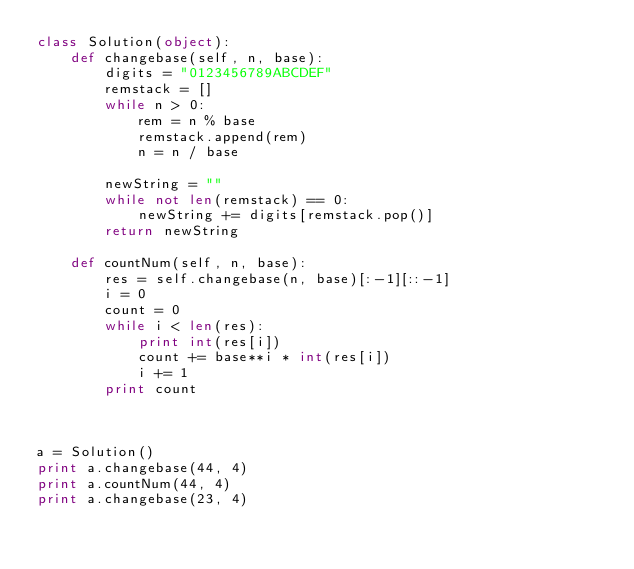Convert code to text. <code><loc_0><loc_0><loc_500><loc_500><_Python_>class Solution(object):
    def changebase(self, n, base):
    	digits = "0123456789ABCDEF"
    	remstack = []
    	while n > 0:
    		rem = n % base 
    		remstack.append(rem)
    		n = n / base

    	newString = ""
    	while not len(remstack) == 0:
    		newString += digits[remstack.pop()]
    	return newString

    def countNum(self, n, base):
    	res = self.changebase(n, base)[:-1][::-1]
    	i = 0
    	count = 0
    	while i < len(res):
    		print int(res[i])
    		count += base**i * int(res[i])
    		i += 1
    	print count 

    	

a = Solution()
print a.changebase(44, 4)
print a.countNum(44, 4)
print a.changebase(23, 4)</code> 